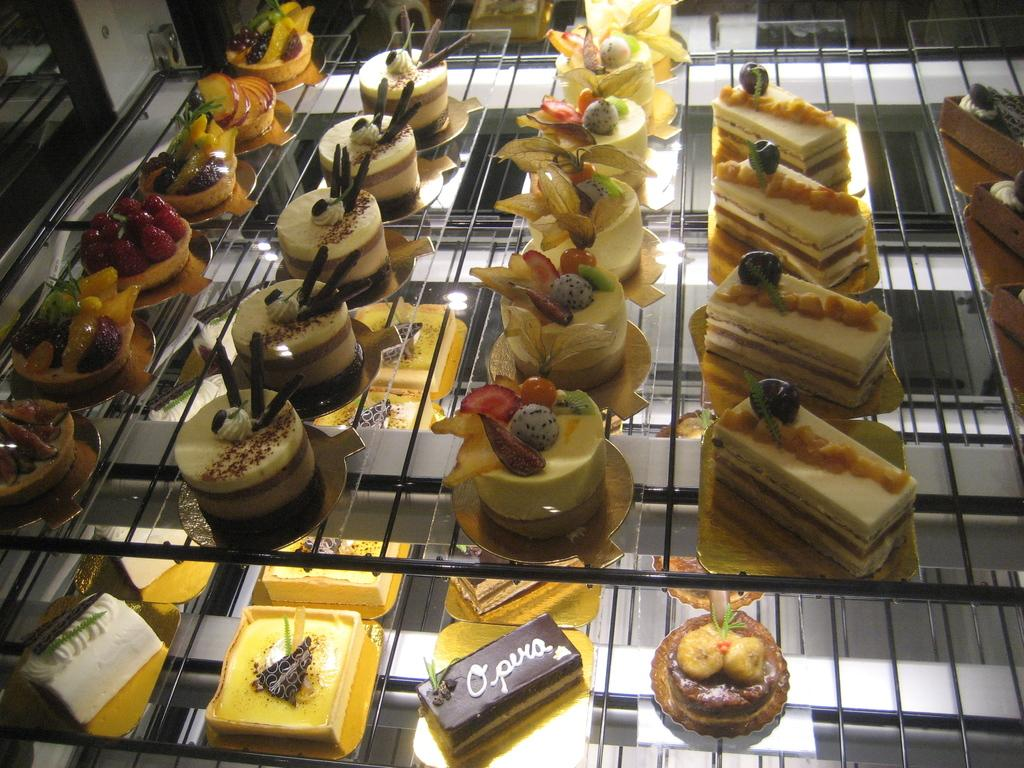What type of food items are visible in the image? There are pastries in the image. How are the pastries arranged or displayed? The pastries are on glass racks. What can be observed about the appearance of the pastries? The pastries are in multiple colors. What type of gloves can be seen in the image? There are no gloves present in the image; it features pastries on glass racks. What type of books are visible in the image? There are no books present in the image; it features pastries on glass racks. 